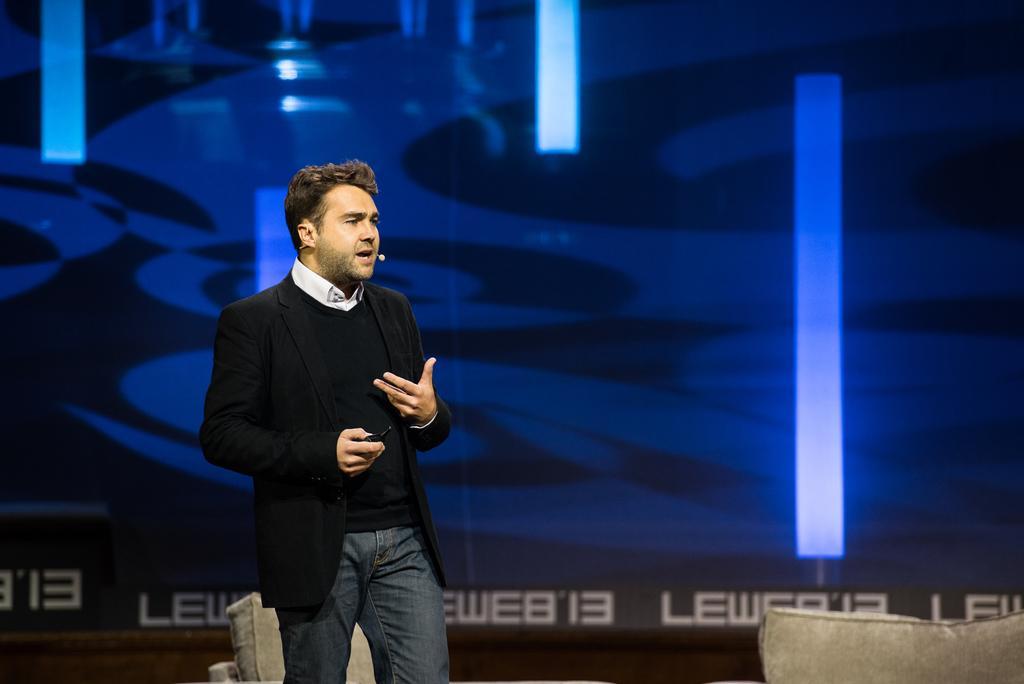In one or two sentences, can you explain what this image depicts? In this picture we can see a man standing in front of a blue background and looking at someone. 